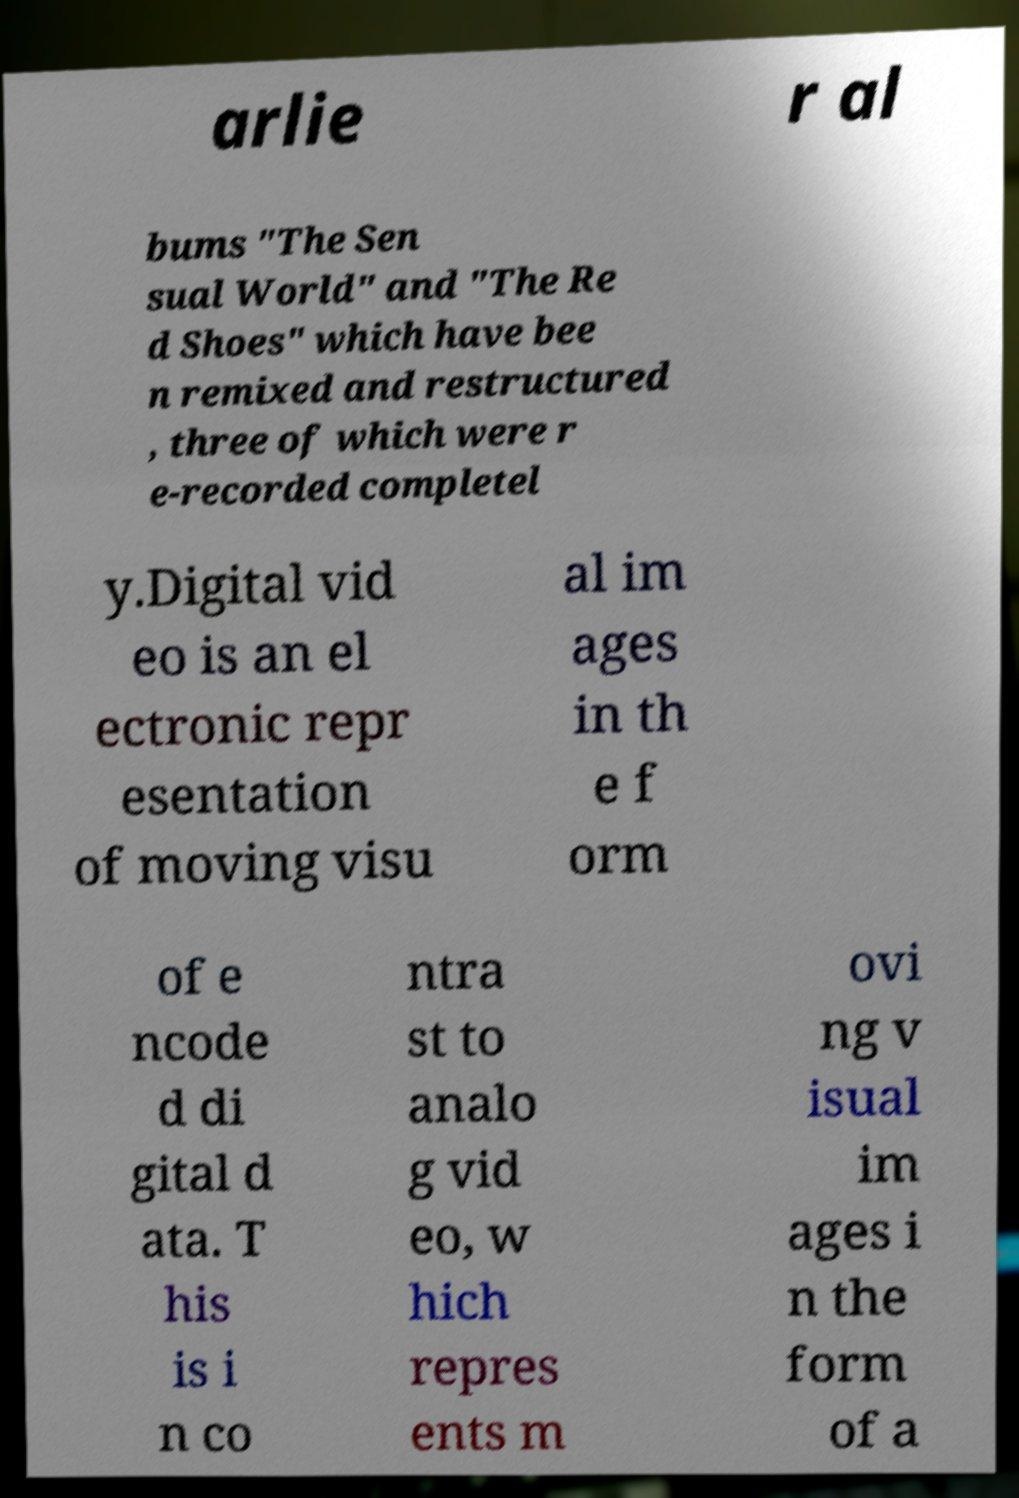What messages or text are displayed in this image? I need them in a readable, typed format. arlie r al bums "The Sen sual World" and "The Re d Shoes" which have bee n remixed and restructured , three of which were r e-recorded completel y.Digital vid eo is an el ectronic repr esentation of moving visu al im ages in th e f orm of e ncode d di gital d ata. T his is i n co ntra st to analo g vid eo, w hich repres ents m ovi ng v isual im ages i n the form of a 